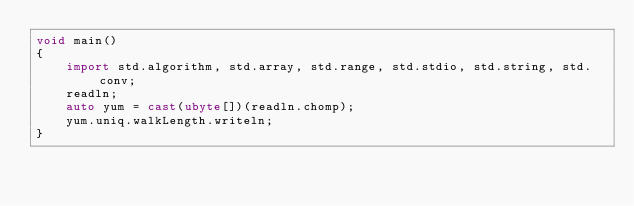Convert code to text. <code><loc_0><loc_0><loc_500><loc_500><_D_>void main()
{
    import std.algorithm, std.array, std.range, std.stdio, std.string, std.conv;
    readln;
    auto yum = cast(ubyte[])(readln.chomp);
    yum.uniq.walkLength.writeln;
}
</code> 